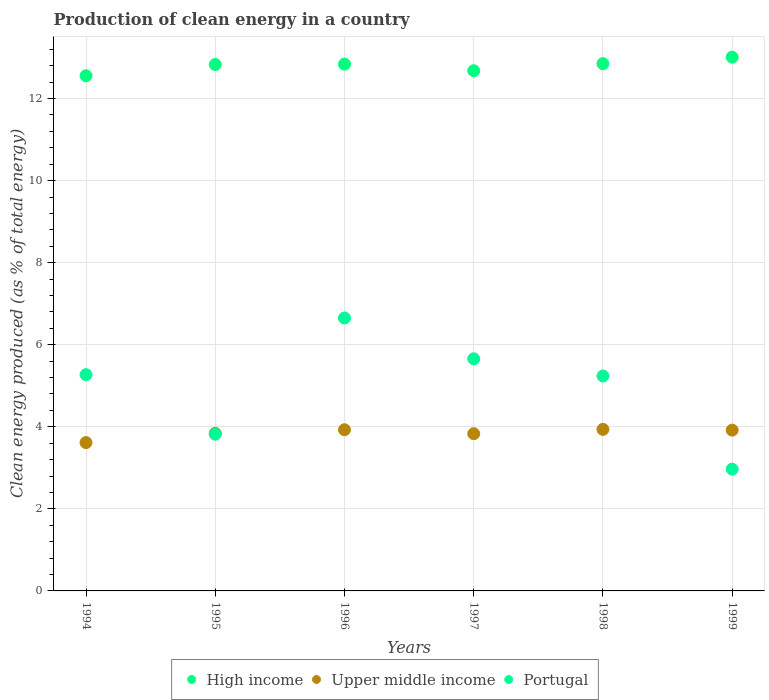What is the percentage of clean energy produced in Upper middle income in 1997?
Give a very brief answer. 3.83. Across all years, what is the maximum percentage of clean energy produced in Upper middle income?
Your response must be concise. 3.94. Across all years, what is the minimum percentage of clean energy produced in Upper middle income?
Your answer should be compact. 3.61. What is the total percentage of clean energy produced in Upper middle income in the graph?
Provide a succinct answer. 23.07. What is the difference between the percentage of clean energy produced in Upper middle income in 1995 and that in 1998?
Your answer should be compact. -0.1. What is the difference between the percentage of clean energy produced in High income in 1995 and the percentage of clean energy produced in Portugal in 1996?
Offer a terse response. 6.18. What is the average percentage of clean energy produced in Upper middle income per year?
Ensure brevity in your answer.  3.85. In the year 1997, what is the difference between the percentage of clean energy produced in Upper middle income and percentage of clean energy produced in High income?
Provide a short and direct response. -8.85. What is the ratio of the percentage of clean energy produced in Upper middle income in 1994 to that in 1996?
Provide a succinct answer. 0.92. Is the percentage of clean energy produced in Upper middle income in 1995 less than that in 1999?
Keep it short and to the point. Yes. Is the difference between the percentage of clean energy produced in Upper middle income in 1996 and 1997 greater than the difference between the percentage of clean energy produced in High income in 1996 and 1997?
Keep it short and to the point. No. What is the difference between the highest and the second highest percentage of clean energy produced in High income?
Give a very brief answer. 0.16. What is the difference between the highest and the lowest percentage of clean energy produced in High income?
Offer a very short reply. 0.45. In how many years, is the percentage of clean energy produced in High income greater than the average percentage of clean energy produced in High income taken over all years?
Your answer should be very brief. 4. Is the percentage of clean energy produced in Portugal strictly less than the percentage of clean energy produced in Upper middle income over the years?
Provide a short and direct response. No. Are the values on the major ticks of Y-axis written in scientific E-notation?
Make the answer very short. No. Does the graph contain grids?
Offer a terse response. Yes. Where does the legend appear in the graph?
Give a very brief answer. Bottom center. How many legend labels are there?
Keep it short and to the point. 3. How are the legend labels stacked?
Your answer should be compact. Horizontal. What is the title of the graph?
Keep it short and to the point. Production of clean energy in a country. Does "Turks and Caicos Islands" appear as one of the legend labels in the graph?
Ensure brevity in your answer.  No. What is the label or title of the Y-axis?
Your response must be concise. Clean energy produced (as % of total energy). What is the Clean energy produced (as % of total energy) of High income in 1994?
Provide a succinct answer. 12.56. What is the Clean energy produced (as % of total energy) in Upper middle income in 1994?
Keep it short and to the point. 3.61. What is the Clean energy produced (as % of total energy) of Portugal in 1994?
Your answer should be compact. 5.27. What is the Clean energy produced (as % of total energy) in High income in 1995?
Keep it short and to the point. 12.83. What is the Clean energy produced (as % of total energy) of Upper middle income in 1995?
Provide a short and direct response. 3.84. What is the Clean energy produced (as % of total energy) of Portugal in 1995?
Keep it short and to the point. 3.82. What is the Clean energy produced (as % of total energy) in High income in 1996?
Offer a very short reply. 12.84. What is the Clean energy produced (as % of total energy) in Upper middle income in 1996?
Your answer should be compact. 3.93. What is the Clean energy produced (as % of total energy) in Portugal in 1996?
Keep it short and to the point. 6.65. What is the Clean energy produced (as % of total energy) in High income in 1997?
Provide a succinct answer. 12.68. What is the Clean energy produced (as % of total energy) of Upper middle income in 1997?
Keep it short and to the point. 3.83. What is the Clean energy produced (as % of total energy) in Portugal in 1997?
Your answer should be very brief. 5.66. What is the Clean energy produced (as % of total energy) in High income in 1998?
Provide a succinct answer. 12.85. What is the Clean energy produced (as % of total energy) in Upper middle income in 1998?
Keep it short and to the point. 3.94. What is the Clean energy produced (as % of total energy) in Portugal in 1998?
Offer a very short reply. 5.24. What is the Clean energy produced (as % of total energy) in High income in 1999?
Offer a very short reply. 13.01. What is the Clean energy produced (as % of total energy) in Upper middle income in 1999?
Your answer should be very brief. 3.92. What is the Clean energy produced (as % of total energy) of Portugal in 1999?
Provide a succinct answer. 2.97. Across all years, what is the maximum Clean energy produced (as % of total energy) in High income?
Keep it short and to the point. 13.01. Across all years, what is the maximum Clean energy produced (as % of total energy) of Upper middle income?
Give a very brief answer. 3.94. Across all years, what is the maximum Clean energy produced (as % of total energy) in Portugal?
Ensure brevity in your answer.  6.65. Across all years, what is the minimum Clean energy produced (as % of total energy) in High income?
Keep it short and to the point. 12.56. Across all years, what is the minimum Clean energy produced (as % of total energy) of Upper middle income?
Your response must be concise. 3.61. Across all years, what is the minimum Clean energy produced (as % of total energy) of Portugal?
Provide a succinct answer. 2.97. What is the total Clean energy produced (as % of total energy) of High income in the graph?
Give a very brief answer. 76.76. What is the total Clean energy produced (as % of total energy) in Upper middle income in the graph?
Make the answer very short. 23.07. What is the total Clean energy produced (as % of total energy) in Portugal in the graph?
Provide a short and direct response. 29.61. What is the difference between the Clean energy produced (as % of total energy) in High income in 1994 and that in 1995?
Offer a very short reply. -0.27. What is the difference between the Clean energy produced (as % of total energy) in Upper middle income in 1994 and that in 1995?
Ensure brevity in your answer.  -0.23. What is the difference between the Clean energy produced (as % of total energy) in Portugal in 1994 and that in 1995?
Your answer should be compact. 1.45. What is the difference between the Clean energy produced (as % of total energy) in High income in 1994 and that in 1996?
Your answer should be compact. -0.28. What is the difference between the Clean energy produced (as % of total energy) in Upper middle income in 1994 and that in 1996?
Offer a very short reply. -0.31. What is the difference between the Clean energy produced (as % of total energy) of Portugal in 1994 and that in 1996?
Your answer should be very brief. -1.38. What is the difference between the Clean energy produced (as % of total energy) of High income in 1994 and that in 1997?
Give a very brief answer. -0.12. What is the difference between the Clean energy produced (as % of total energy) in Upper middle income in 1994 and that in 1997?
Provide a short and direct response. -0.22. What is the difference between the Clean energy produced (as % of total energy) in Portugal in 1994 and that in 1997?
Your answer should be compact. -0.39. What is the difference between the Clean energy produced (as % of total energy) in High income in 1994 and that in 1998?
Ensure brevity in your answer.  -0.29. What is the difference between the Clean energy produced (as % of total energy) in Upper middle income in 1994 and that in 1998?
Make the answer very short. -0.32. What is the difference between the Clean energy produced (as % of total energy) in Portugal in 1994 and that in 1998?
Keep it short and to the point. 0.03. What is the difference between the Clean energy produced (as % of total energy) in High income in 1994 and that in 1999?
Ensure brevity in your answer.  -0.45. What is the difference between the Clean energy produced (as % of total energy) in Upper middle income in 1994 and that in 1999?
Provide a succinct answer. -0.3. What is the difference between the Clean energy produced (as % of total energy) in Portugal in 1994 and that in 1999?
Your response must be concise. 2.3. What is the difference between the Clean energy produced (as % of total energy) of High income in 1995 and that in 1996?
Offer a very short reply. -0.01. What is the difference between the Clean energy produced (as % of total energy) in Upper middle income in 1995 and that in 1996?
Your answer should be compact. -0.09. What is the difference between the Clean energy produced (as % of total energy) in Portugal in 1995 and that in 1996?
Your response must be concise. -2.83. What is the difference between the Clean energy produced (as % of total energy) in High income in 1995 and that in 1997?
Provide a succinct answer. 0.15. What is the difference between the Clean energy produced (as % of total energy) of Upper middle income in 1995 and that in 1997?
Your answer should be compact. 0.01. What is the difference between the Clean energy produced (as % of total energy) in Portugal in 1995 and that in 1997?
Offer a very short reply. -1.84. What is the difference between the Clean energy produced (as % of total energy) in High income in 1995 and that in 1998?
Give a very brief answer. -0.02. What is the difference between the Clean energy produced (as % of total energy) in Upper middle income in 1995 and that in 1998?
Offer a very short reply. -0.1. What is the difference between the Clean energy produced (as % of total energy) in Portugal in 1995 and that in 1998?
Ensure brevity in your answer.  -1.42. What is the difference between the Clean energy produced (as % of total energy) of High income in 1995 and that in 1999?
Your answer should be very brief. -0.18. What is the difference between the Clean energy produced (as % of total energy) in Upper middle income in 1995 and that in 1999?
Your response must be concise. -0.08. What is the difference between the Clean energy produced (as % of total energy) of Portugal in 1995 and that in 1999?
Keep it short and to the point. 0.85. What is the difference between the Clean energy produced (as % of total energy) in High income in 1996 and that in 1997?
Offer a very short reply. 0.16. What is the difference between the Clean energy produced (as % of total energy) of Upper middle income in 1996 and that in 1997?
Provide a succinct answer. 0.1. What is the difference between the Clean energy produced (as % of total energy) in High income in 1996 and that in 1998?
Offer a terse response. -0.01. What is the difference between the Clean energy produced (as % of total energy) of Upper middle income in 1996 and that in 1998?
Provide a succinct answer. -0.01. What is the difference between the Clean energy produced (as % of total energy) in Portugal in 1996 and that in 1998?
Your answer should be very brief. 1.41. What is the difference between the Clean energy produced (as % of total energy) in High income in 1996 and that in 1999?
Offer a terse response. -0.17. What is the difference between the Clean energy produced (as % of total energy) of Upper middle income in 1996 and that in 1999?
Your response must be concise. 0.01. What is the difference between the Clean energy produced (as % of total energy) in Portugal in 1996 and that in 1999?
Give a very brief answer. 3.68. What is the difference between the Clean energy produced (as % of total energy) in High income in 1997 and that in 1998?
Your response must be concise. -0.17. What is the difference between the Clean energy produced (as % of total energy) in Upper middle income in 1997 and that in 1998?
Offer a very short reply. -0.1. What is the difference between the Clean energy produced (as % of total energy) of Portugal in 1997 and that in 1998?
Ensure brevity in your answer.  0.42. What is the difference between the Clean energy produced (as % of total energy) of High income in 1997 and that in 1999?
Provide a short and direct response. -0.33. What is the difference between the Clean energy produced (as % of total energy) in Upper middle income in 1997 and that in 1999?
Your response must be concise. -0.09. What is the difference between the Clean energy produced (as % of total energy) of Portugal in 1997 and that in 1999?
Provide a short and direct response. 2.69. What is the difference between the Clean energy produced (as % of total energy) of High income in 1998 and that in 1999?
Your answer should be very brief. -0.16. What is the difference between the Clean energy produced (as % of total energy) of Upper middle income in 1998 and that in 1999?
Offer a terse response. 0.02. What is the difference between the Clean energy produced (as % of total energy) of Portugal in 1998 and that in 1999?
Ensure brevity in your answer.  2.27. What is the difference between the Clean energy produced (as % of total energy) in High income in 1994 and the Clean energy produced (as % of total energy) in Upper middle income in 1995?
Offer a terse response. 8.72. What is the difference between the Clean energy produced (as % of total energy) of High income in 1994 and the Clean energy produced (as % of total energy) of Portugal in 1995?
Give a very brief answer. 8.74. What is the difference between the Clean energy produced (as % of total energy) of Upper middle income in 1994 and the Clean energy produced (as % of total energy) of Portugal in 1995?
Provide a short and direct response. -0.21. What is the difference between the Clean energy produced (as % of total energy) of High income in 1994 and the Clean energy produced (as % of total energy) of Upper middle income in 1996?
Your answer should be compact. 8.63. What is the difference between the Clean energy produced (as % of total energy) of High income in 1994 and the Clean energy produced (as % of total energy) of Portugal in 1996?
Offer a very short reply. 5.9. What is the difference between the Clean energy produced (as % of total energy) of Upper middle income in 1994 and the Clean energy produced (as % of total energy) of Portugal in 1996?
Make the answer very short. -3.04. What is the difference between the Clean energy produced (as % of total energy) in High income in 1994 and the Clean energy produced (as % of total energy) in Upper middle income in 1997?
Your response must be concise. 8.72. What is the difference between the Clean energy produced (as % of total energy) in High income in 1994 and the Clean energy produced (as % of total energy) in Portugal in 1997?
Your response must be concise. 6.9. What is the difference between the Clean energy produced (as % of total energy) in Upper middle income in 1994 and the Clean energy produced (as % of total energy) in Portugal in 1997?
Your answer should be compact. -2.04. What is the difference between the Clean energy produced (as % of total energy) in High income in 1994 and the Clean energy produced (as % of total energy) in Upper middle income in 1998?
Your answer should be very brief. 8.62. What is the difference between the Clean energy produced (as % of total energy) in High income in 1994 and the Clean energy produced (as % of total energy) in Portugal in 1998?
Ensure brevity in your answer.  7.32. What is the difference between the Clean energy produced (as % of total energy) of Upper middle income in 1994 and the Clean energy produced (as % of total energy) of Portugal in 1998?
Your response must be concise. -1.62. What is the difference between the Clean energy produced (as % of total energy) in High income in 1994 and the Clean energy produced (as % of total energy) in Upper middle income in 1999?
Give a very brief answer. 8.64. What is the difference between the Clean energy produced (as % of total energy) of High income in 1994 and the Clean energy produced (as % of total energy) of Portugal in 1999?
Keep it short and to the point. 9.59. What is the difference between the Clean energy produced (as % of total energy) of Upper middle income in 1994 and the Clean energy produced (as % of total energy) of Portugal in 1999?
Provide a short and direct response. 0.65. What is the difference between the Clean energy produced (as % of total energy) in High income in 1995 and the Clean energy produced (as % of total energy) in Upper middle income in 1996?
Keep it short and to the point. 8.9. What is the difference between the Clean energy produced (as % of total energy) in High income in 1995 and the Clean energy produced (as % of total energy) in Portugal in 1996?
Make the answer very short. 6.18. What is the difference between the Clean energy produced (as % of total energy) of Upper middle income in 1995 and the Clean energy produced (as % of total energy) of Portugal in 1996?
Provide a succinct answer. -2.81. What is the difference between the Clean energy produced (as % of total energy) in High income in 1995 and the Clean energy produced (as % of total energy) in Upper middle income in 1997?
Your answer should be compact. 9. What is the difference between the Clean energy produced (as % of total energy) in High income in 1995 and the Clean energy produced (as % of total energy) in Portugal in 1997?
Your answer should be very brief. 7.17. What is the difference between the Clean energy produced (as % of total energy) of Upper middle income in 1995 and the Clean energy produced (as % of total energy) of Portugal in 1997?
Offer a terse response. -1.82. What is the difference between the Clean energy produced (as % of total energy) of High income in 1995 and the Clean energy produced (as % of total energy) of Upper middle income in 1998?
Provide a succinct answer. 8.89. What is the difference between the Clean energy produced (as % of total energy) of High income in 1995 and the Clean energy produced (as % of total energy) of Portugal in 1998?
Your answer should be compact. 7.59. What is the difference between the Clean energy produced (as % of total energy) of Upper middle income in 1995 and the Clean energy produced (as % of total energy) of Portugal in 1998?
Ensure brevity in your answer.  -1.4. What is the difference between the Clean energy produced (as % of total energy) of High income in 1995 and the Clean energy produced (as % of total energy) of Upper middle income in 1999?
Keep it short and to the point. 8.91. What is the difference between the Clean energy produced (as % of total energy) of High income in 1995 and the Clean energy produced (as % of total energy) of Portugal in 1999?
Provide a short and direct response. 9.86. What is the difference between the Clean energy produced (as % of total energy) of Upper middle income in 1995 and the Clean energy produced (as % of total energy) of Portugal in 1999?
Give a very brief answer. 0.87. What is the difference between the Clean energy produced (as % of total energy) of High income in 1996 and the Clean energy produced (as % of total energy) of Upper middle income in 1997?
Your answer should be compact. 9.01. What is the difference between the Clean energy produced (as % of total energy) in High income in 1996 and the Clean energy produced (as % of total energy) in Portugal in 1997?
Your answer should be very brief. 7.18. What is the difference between the Clean energy produced (as % of total energy) in Upper middle income in 1996 and the Clean energy produced (as % of total energy) in Portugal in 1997?
Ensure brevity in your answer.  -1.73. What is the difference between the Clean energy produced (as % of total energy) in High income in 1996 and the Clean energy produced (as % of total energy) in Upper middle income in 1998?
Keep it short and to the point. 8.9. What is the difference between the Clean energy produced (as % of total energy) of High income in 1996 and the Clean energy produced (as % of total energy) of Portugal in 1998?
Offer a very short reply. 7.6. What is the difference between the Clean energy produced (as % of total energy) in Upper middle income in 1996 and the Clean energy produced (as % of total energy) in Portugal in 1998?
Keep it short and to the point. -1.31. What is the difference between the Clean energy produced (as % of total energy) in High income in 1996 and the Clean energy produced (as % of total energy) in Upper middle income in 1999?
Give a very brief answer. 8.92. What is the difference between the Clean energy produced (as % of total energy) of High income in 1996 and the Clean energy produced (as % of total energy) of Portugal in 1999?
Your answer should be compact. 9.87. What is the difference between the Clean energy produced (as % of total energy) of Upper middle income in 1996 and the Clean energy produced (as % of total energy) of Portugal in 1999?
Keep it short and to the point. 0.96. What is the difference between the Clean energy produced (as % of total energy) in High income in 1997 and the Clean energy produced (as % of total energy) in Upper middle income in 1998?
Your answer should be compact. 8.74. What is the difference between the Clean energy produced (as % of total energy) in High income in 1997 and the Clean energy produced (as % of total energy) in Portugal in 1998?
Make the answer very short. 7.44. What is the difference between the Clean energy produced (as % of total energy) of Upper middle income in 1997 and the Clean energy produced (as % of total energy) of Portugal in 1998?
Give a very brief answer. -1.41. What is the difference between the Clean energy produced (as % of total energy) of High income in 1997 and the Clean energy produced (as % of total energy) of Upper middle income in 1999?
Make the answer very short. 8.76. What is the difference between the Clean energy produced (as % of total energy) of High income in 1997 and the Clean energy produced (as % of total energy) of Portugal in 1999?
Offer a very short reply. 9.71. What is the difference between the Clean energy produced (as % of total energy) of Upper middle income in 1997 and the Clean energy produced (as % of total energy) of Portugal in 1999?
Your answer should be compact. 0.86. What is the difference between the Clean energy produced (as % of total energy) in High income in 1998 and the Clean energy produced (as % of total energy) in Upper middle income in 1999?
Your answer should be compact. 8.93. What is the difference between the Clean energy produced (as % of total energy) of High income in 1998 and the Clean energy produced (as % of total energy) of Portugal in 1999?
Your response must be concise. 9.88. What is the difference between the Clean energy produced (as % of total energy) in Upper middle income in 1998 and the Clean energy produced (as % of total energy) in Portugal in 1999?
Your answer should be compact. 0.97. What is the average Clean energy produced (as % of total energy) in High income per year?
Ensure brevity in your answer.  12.79. What is the average Clean energy produced (as % of total energy) of Upper middle income per year?
Your response must be concise. 3.85. What is the average Clean energy produced (as % of total energy) of Portugal per year?
Give a very brief answer. 4.93. In the year 1994, what is the difference between the Clean energy produced (as % of total energy) in High income and Clean energy produced (as % of total energy) in Upper middle income?
Keep it short and to the point. 8.94. In the year 1994, what is the difference between the Clean energy produced (as % of total energy) of High income and Clean energy produced (as % of total energy) of Portugal?
Keep it short and to the point. 7.29. In the year 1994, what is the difference between the Clean energy produced (as % of total energy) in Upper middle income and Clean energy produced (as % of total energy) in Portugal?
Ensure brevity in your answer.  -1.66. In the year 1995, what is the difference between the Clean energy produced (as % of total energy) in High income and Clean energy produced (as % of total energy) in Upper middle income?
Offer a very short reply. 8.99. In the year 1995, what is the difference between the Clean energy produced (as % of total energy) in High income and Clean energy produced (as % of total energy) in Portugal?
Make the answer very short. 9.01. In the year 1995, what is the difference between the Clean energy produced (as % of total energy) of Upper middle income and Clean energy produced (as % of total energy) of Portugal?
Offer a very short reply. 0.02. In the year 1996, what is the difference between the Clean energy produced (as % of total energy) in High income and Clean energy produced (as % of total energy) in Upper middle income?
Ensure brevity in your answer.  8.91. In the year 1996, what is the difference between the Clean energy produced (as % of total energy) in High income and Clean energy produced (as % of total energy) in Portugal?
Make the answer very short. 6.19. In the year 1996, what is the difference between the Clean energy produced (as % of total energy) of Upper middle income and Clean energy produced (as % of total energy) of Portugal?
Your answer should be very brief. -2.72. In the year 1997, what is the difference between the Clean energy produced (as % of total energy) of High income and Clean energy produced (as % of total energy) of Upper middle income?
Ensure brevity in your answer.  8.85. In the year 1997, what is the difference between the Clean energy produced (as % of total energy) in High income and Clean energy produced (as % of total energy) in Portugal?
Give a very brief answer. 7.02. In the year 1997, what is the difference between the Clean energy produced (as % of total energy) of Upper middle income and Clean energy produced (as % of total energy) of Portugal?
Ensure brevity in your answer.  -1.83. In the year 1998, what is the difference between the Clean energy produced (as % of total energy) in High income and Clean energy produced (as % of total energy) in Upper middle income?
Make the answer very short. 8.91. In the year 1998, what is the difference between the Clean energy produced (as % of total energy) in High income and Clean energy produced (as % of total energy) in Portugal?
Keep it short and to the point. 7.61. In the year 1998, what is the difference between the Clean energy produced (as % of total energy) of Upper middle income and Clean energy produced (as % of total energy) of Portugal?
Your answer should be compact. -1.3. In the year 1999, what is the difference between the Clean energy produced (as % of total energy) of High income and Clean energy produced (as % of total energy) of Upper middle income?
Keep it short and to the point. 9.09. In the year 1999, what is the difference between the Clean energy produced (as % of total energy) in High income and Clean energy produced (as % of total energy) in Portugal?
Provide a short and direct response. 10.04. In the year 1999, what is the difference between the Clean energy produced (as % of total energy) of Upper middle income and Clean energy produced (as % of total energy) of Portugal?
Your answer should be compact. 0.95. What is the ratio of the Clean energy produced (as % of total energy) of High income in 1994 to that in 1995?
Your answer should be compact. 0.98. What is the ratio of the Clean energy produced (as % of total energy) of Upper middle income in 1994 to that in 1995?
Your answer should be very brief. 0.94. What is the ratio of the Clean energy produced (as % of total energy) in Portugal in 1994 to that in 1995?
Give a very brief answer. 1.38. What is the ratio of the Clean energy produced (as % of total energy) of High income in 1994 to that in 1996?
Make the answer very short. 0.98. What is the ratio of the Clean energy produced (as % of total energy) of Upper middle income in 1994 to that in 1996?
Your response must be concise. 0.92. What is the ratio of the Clean energy produced (as % of total energy) of Portugal in 1994 to that in 1996?
Your answer should be very brief. 0.79. What is the ratio of the Clean energy produced (as % of total energy) of High income in 1994 to that in 1997?
Provide a short and direct response. 0.99. What is the ratio of the Clean energy produced (as % of total energy) in Upper middle income in 1994 to that in 1997?
Keep it short and to the point. 0.94. What is the ratio of the Clean energy produced (as % of total energy) of Portugal in 1994 to that in 1997?
Provide a short and direct response. 0.93. What is the ratio of the Clean energy produced (as % of total energy) in High income in 1994 to that in 1998?
Your answer should be compact. 0.98. What is the ratio of the Clean energy produced (as % of total energy) of Upper middle income in 1994 to that in 1998?
Keep it short and to the point. 0.92. What is the ratio of the Clean energy produced (as % of total energy) of High income in 1994 to that in 1999?
Ensure brevity in your answer.  0.97. What is the ratio of the Clean energy produced (as % of total energy) in Upper middle income in 1994 to that in 1999?
Make the answer very short. 0.92. What is the ratio of the Clean energy produced (as % of total energy) in Portugal in 1994 to that in 1999?
Provide a succinct answer. 1.78. What is the ratio of the Clean energy produced (as % of total energy) of Upper middle income in 1995 to that in 1996?
Keep it short and to the point. 0.98. What is the ratio of the Clean energy produced (as % of total energy) of Portugal in 1995 to that in 1996?
Give a very brief answer. 0.57. What is the ratio of the Clean energy produced (as % of total energy) of High income in 1995 to that in 1997?
Provide a succinct answer. 1.01. What is the ratio of the Clean energy produced (as % of total energy) in Portugal in 1995 to that in 1997?
Provide a succinct answer. 0.68. What is the ratio of the Clean energy produced (as % of total energy) in High income in 1995 to that in 1998?
Provide a succinct answer. 1. What is the ratio of the Clean energy produced (as % of total energy) in Upper middle income in 1995 to that in 1998?
Your answer should be very brief. 0.98. What is the ratio of the Clean energy produced (as % of total energy) of Portugal in 1995 to that in 1998?
Give a very brief answer. 0.73. What is the ratio of the Clean energy produced (as % of total energy) in High income in 1995 to that in 1999?
Offer a terse response. 0.99. What is the ratio of the Clean energy produced (as % of total energy) in Upper middle income in 1995 to that in 1999?
Keep it short and to the point. 0.98. What is the ratio of the Clean energy produced (as % of total energy) of Portugal in 1995 to that in 1999?
Your response must be concise. 1.29. What is the ratio of the Clean energy produced (as % of total energy) in High income in 1996 to that in 1997?
Your answer should be compact. 1.01. What is the ratio of the Clean energy produced (as % of total energy) in Upper middle income in 1996 to that in 1997?
Provide a succinct answer. 1.03. What is the ratio of the Clean energy produced (as % of total energy) in Portugal in 1996 to that in 1997?
Provide a short and direct response. 1.18. What is the ratio of the Clean energy produced (as % of total energy) of Portugal in 1996 to that in 1998?
Your answer should be compact. 1.27. What is the ratio of the Clean energy produced (as % of total energy) in High income in 1996 to that in 1999?
Provide a short and direct response. 0.99. What is the ratio of the Clean energy produced (as % of total energy) in Upper middle income in 1996 to that in 1999?
Provide a succinct answer. 1. What is the ratio of the Clean energy produced (as % of total energy) in Portugal in 1996 to that in 1999?
Give a very brief answer. 2.24. What is the ratio of the Clean energy produced (as % of total energy) in High income in 1997 to that in 1998?
Offer a terse response. 0.99. What is the ratio of the Clean energy produced (as % of total energy) of Upper middle income in 1997 to that in 1998?
Keep it short and to the point. 0.97. What is the ratio of the Clean energy produced (as % of total energy) of Portugal in 1997 to that in 1998?
Your answer should be very brief. 1.08. What is the ratio of the Clean energy produced (as % of total energy) in High income in 1997 to that in 1999?
Make the answer very short. 0.97. What is the ratio of the Clean energy produced (as % of total energy) of Upper middle income in 1997 to that in 1999?
Your answer should be compact. 0.98. What is the ratio of the Clean energy produced (as % of total energy) of Portugal in 1997 to that in 1999?
Offer a terse response. 1.91. What is the ratio of the Clean energy produced (as % of total energy) of Portugal in 1998 to that in 1999?
Offer a very short reply. 1.76. What is the difference between the highest and the second highest Clean energy produced (as % of total energy) of High income?
Provide a succinct answer. 0.16. What is the difference between the highest and the second highest Clean energy produced (as % of total energy) of Upper middle income?
Your answer should be very brief. 0.01. What is the difference between the highest and the lowest Clean energy produced (as % of total energy) of High income?
Keep it short and to the point. 0.45. What is the difference between the highest and the lowest Clean energy produced (as % of total energy) of Upper middle income?
Give a very brief answer. 0.32. What is the difference between the highest and the lowest Clean energy produced (as % of total energy) in Portugal?
Make the answer very short. 3.68. 